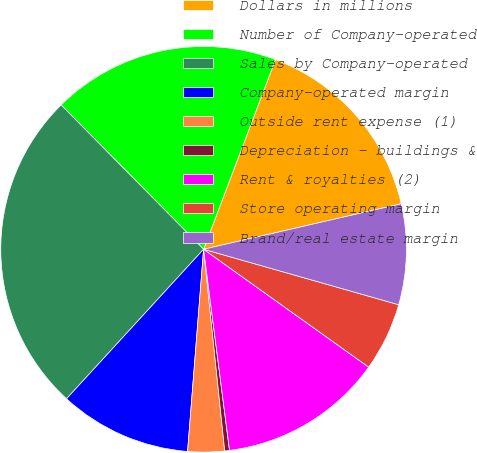Convert chart. <chart><loc_0><loc_0><loc_500><loc_500><pie_chart><fcel>Dollars in millions<fcel>Number of Company-operated<fcel>Sales by Company-operated<fcel>Company-operated margin<fcel>Outside rent expense (1)<fcel>Depreciation - buildings &<fcel>Rent & royalties (2)<fcel>Store operating margin<fcel>Brand/real estate margin<nl><fcel>15.63%<fcel>18.17%<fcel>25.79%<fcel>10.55%<fcel>2.92%<fcel>0.38%<fcel>13.09%<fcel>5.46%<fcel>8.01%<nl></chart> 